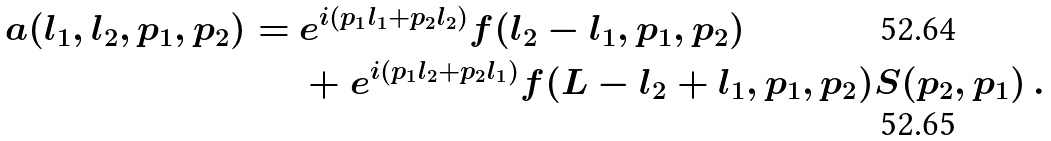Convert formula to latex. <formula><loc_0><loc_0><loc_500><loc_500>a ( l _ { 1 } , l _ { 2 } , p _ { 1 } , p _ { 2 } ) = \ & e ^ { i ( p _ { 1 } l _ { 1 } + p _ { 2 } l _ { 2 } ) } f ( l _ { 2 } - l _ { 1 } , p _ { 1 } , p _ { 2 } ) \\ & + e ^ { i ( p _ { 1 } l _ { 2 } + p _ { 2 } l _ { 1 } ) } f ( L - l _ { 2 } + l _ { 1 } , p _ { 1 } , p _ { 2 } ) S ( p _ { 2 } , p _ { 1 } ) \, .</formula> 